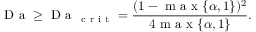Convert formula to latex. <formula><loc_0><loc_0><loc_500><loc_500>D a \geq D a _ { c r i t } = \frac { ( 1 - m a x \{ \alpha , 1 \} ) ^ { 2 } } { 4 m a x \{ \alpha , 1 \} } .</formula> 